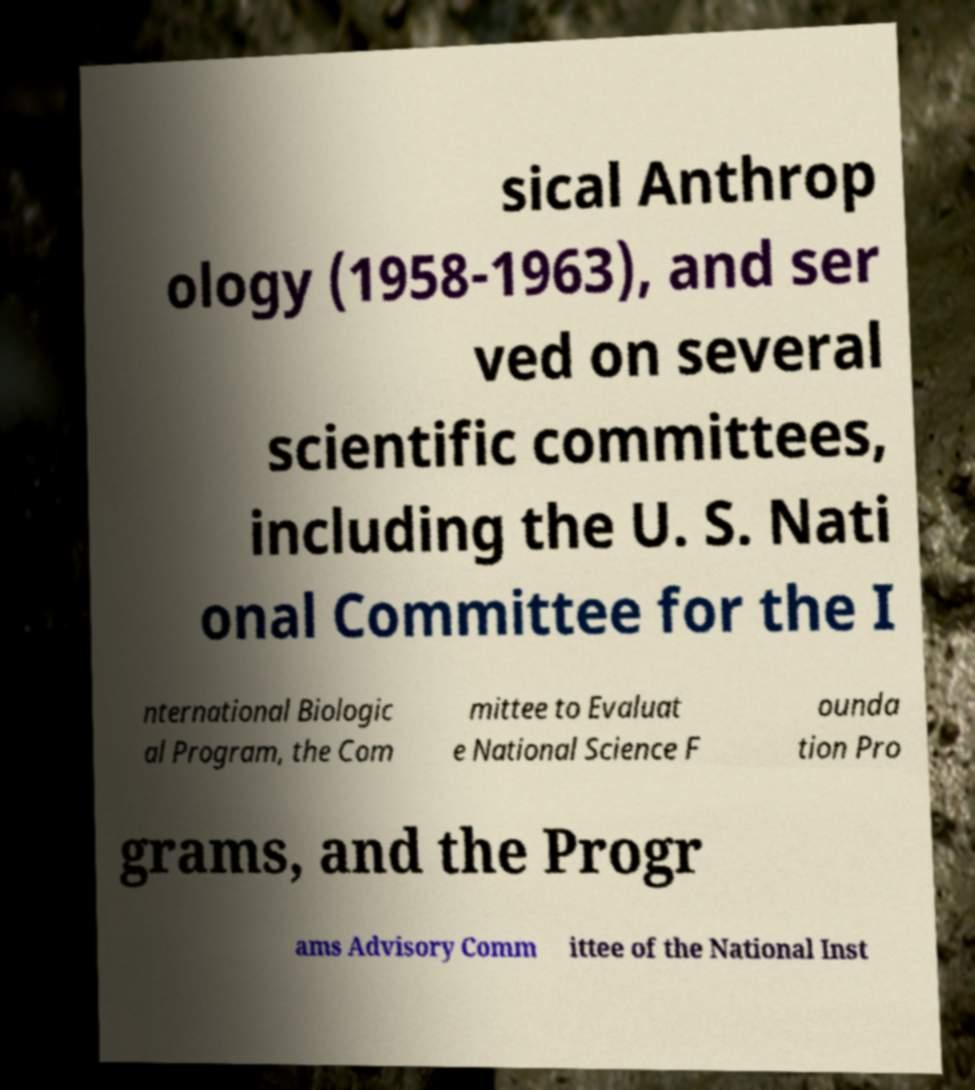What messages or text are displayed in this image? I need them in a readable, typed format. sical Anthrop ology (1958-1963), and ser ved on several scientific committees, including the U. S. Nati onal Committee for the I nternational Biologic al Program, the Com mittee to Evaluat e National Science F ounda tion Pro grams, and the Progr ams Advisory Comm ittee of the National Inst 